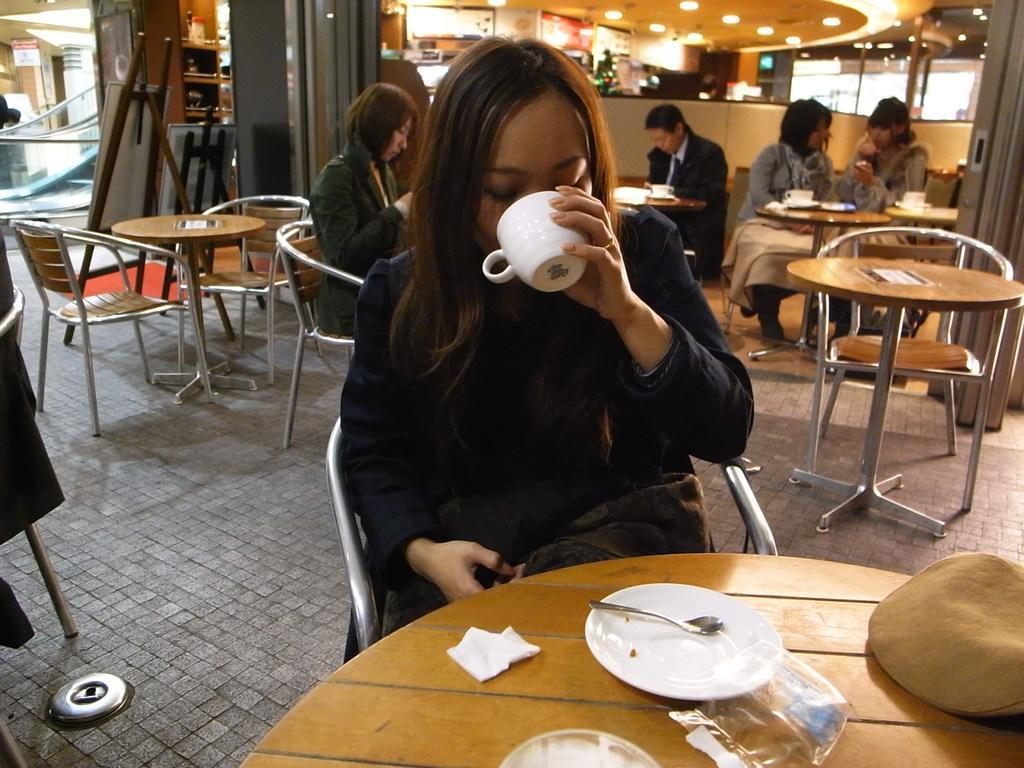Describe this image in one or two sentences. This picture shows a woman seated and drinking coffee with the cup and we see few people seated on her back and we see a saucer and spoon on the table 